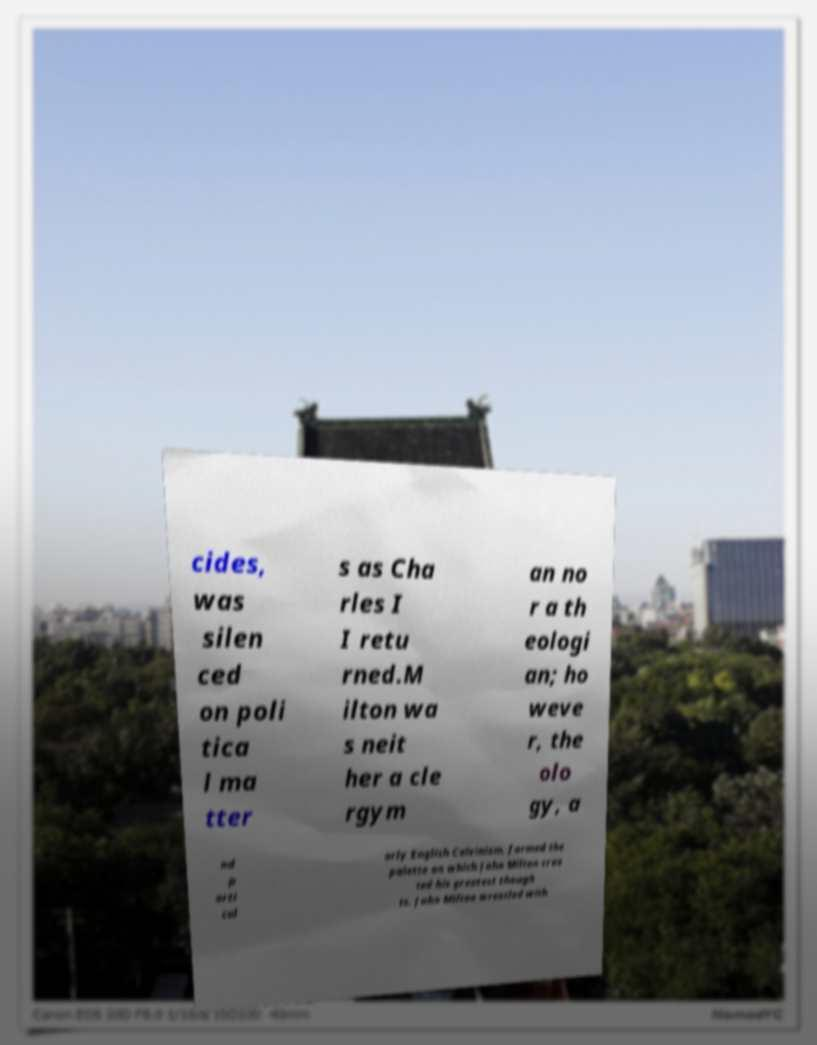Please identify and transcribe the text found in this image. cides, was silen ced on poli tica l ma tter s as Cha rles I I retu rned.M ilton wa s neit her a cle rgym an no r a th eologi an; ho weve r, the olo gy, a nd p arti cul arly English Calvinism, formed the palette on which John Milton crea ted his greatest though ts. John Milton wrestled with 